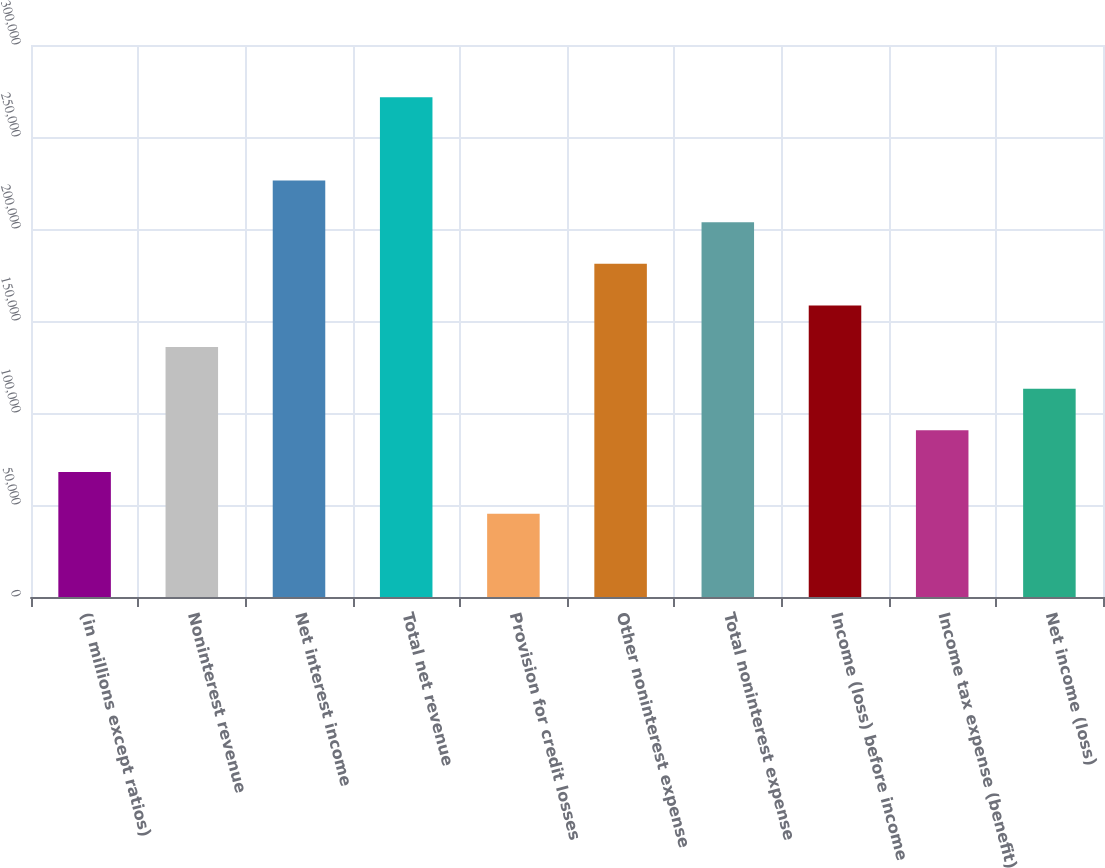<chart> <loc_0><loc_0><loc_500><loc_500><bar_chart><fcel>(in millions except ratios)<fcel>Noninterest revenue<fcel>Net interest income<fcel>Total net revenue<fcel>Provision for credit losses<fcel>Other noninterest expense<fcel>Total noninterest expense<fcel>Income (loss) before income<fcel>Income tax expense (benefit)<fcel>Net income (loss)<nl><fcel>67928.6<fcel>135831<fcel>226368<fcel>271636<fcel>45294.4<fcel>181100<fcel>203734<fcel>158465<fcel>90562.8<fcel>113197<nl></chart> 